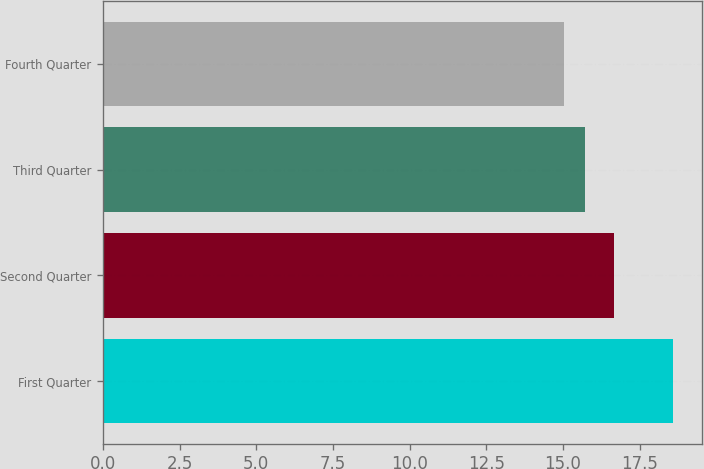Convert chart to OTSL. <chart><loc_0><loc_0><loc_500><loc_500><bar_chart><fcel>First Quarter<fcel>Second Quarter<fcel>Third Quarter<fcel>Fourth Quarter<nl><fcel>18.59<fcel>16.67<fcel>15.72<fcel>15.03<nl></chart> 